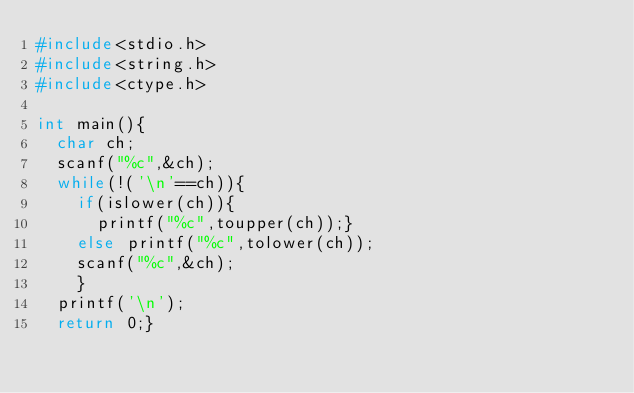Convert code to text. <code><loc_0><loc_0><loc_500><loc_500><_C_>#include<stdio.h>
#include<string.h>
#include<ctype.h>

int main(){
  char ch;
  scanf("%c",&ch);
  while(!('\n'==ch)){
    if(islower(ch)){
      printf("%c",toupper(ch));}
    else printf("%c",tolower(ch));
    scanf("%c",&ch);
    }
  printf('\n');
  return 0;}</code> 